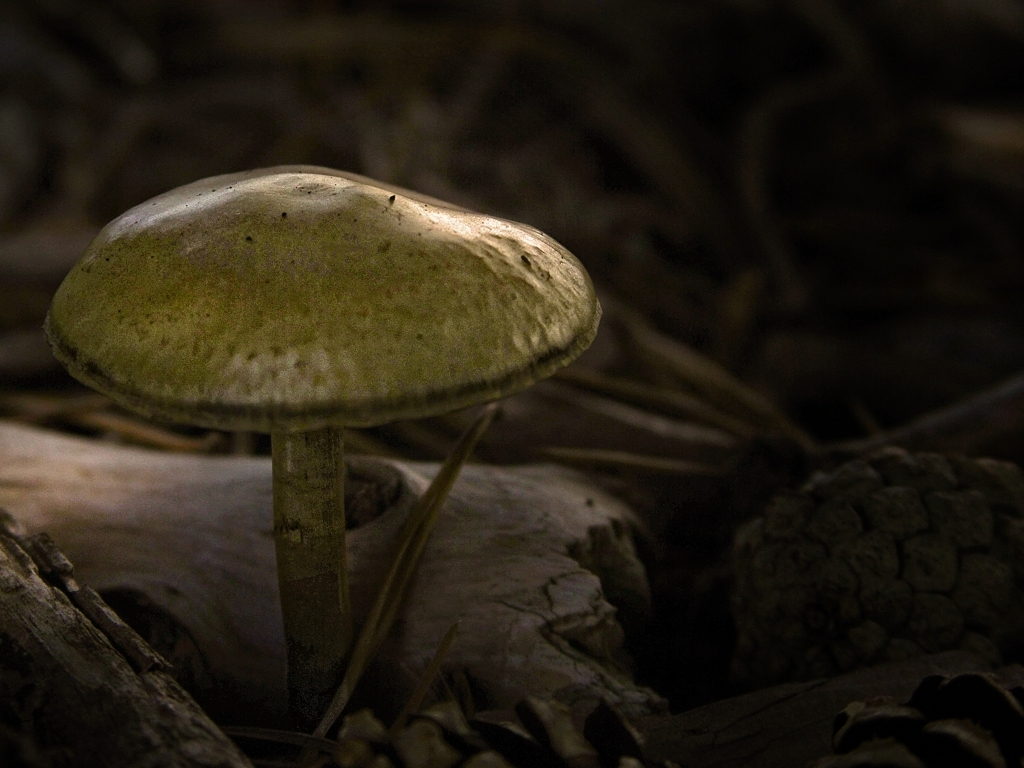Could this mushroom be edible or is it potentially dangerous? Without being able to identify the specific species, it's impossible to determine if this mushroom is edible or poisonous. It's important never to consume wild mushrooms without expertise, as many edible mushrooms have toxic look-alikes. 